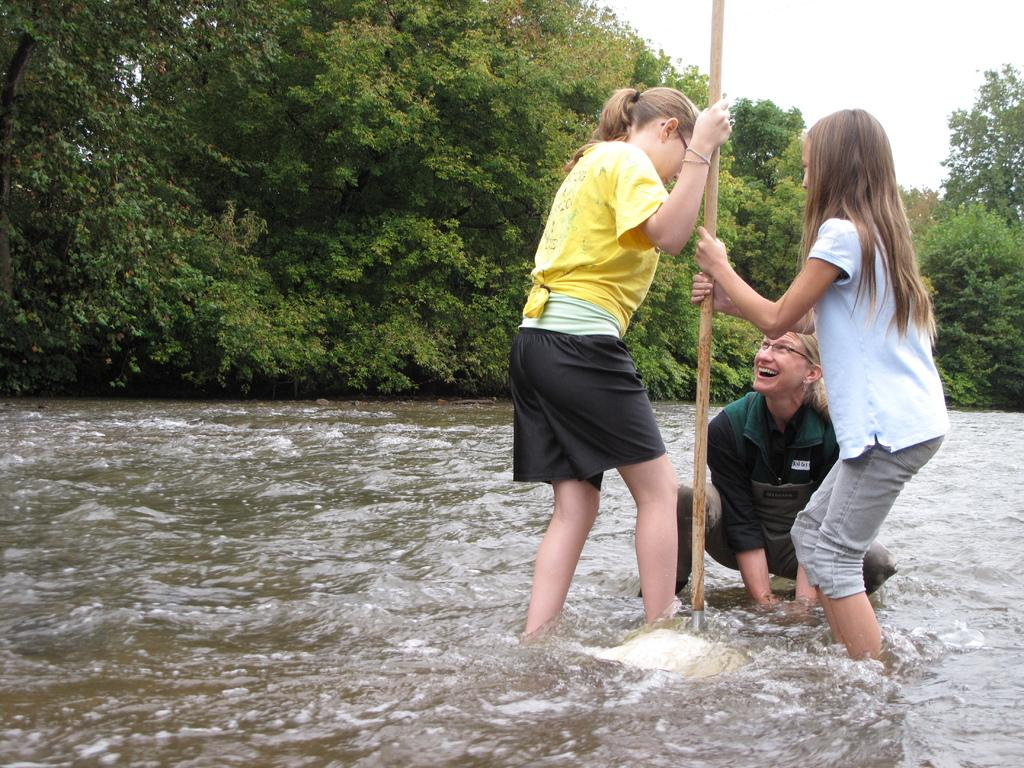What are the people in the image doing? The people in the image are in the water. What are some of the people holding? Some people are holding an object. What can be seen in the background of the image? There are trees visible in the image. What is visible above the people and trees? The sky is visible in the image. What color is the orange hair of the person in the image? There is no person with orange hair in the image. 